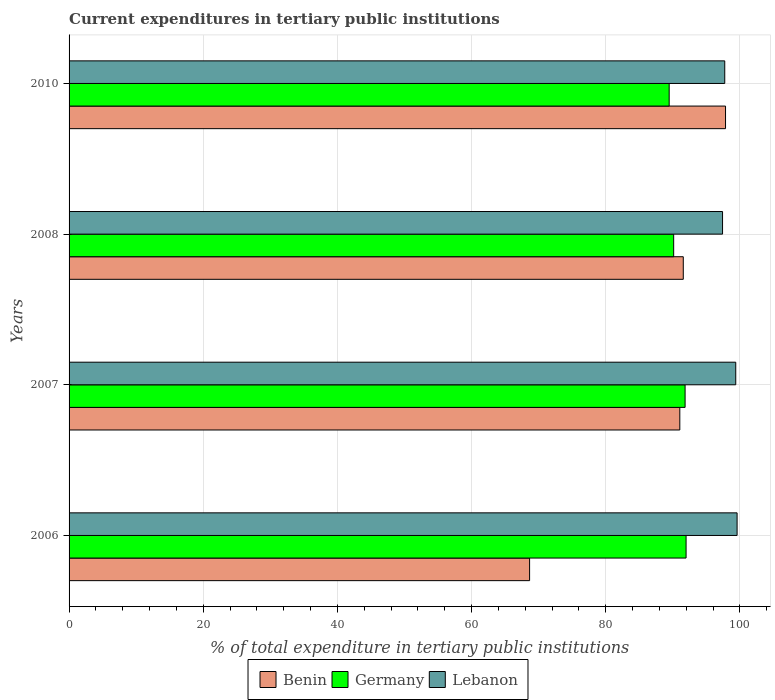How many bars are there on the 2nd tick from the top?
Provide a short and direct response. 3. How many bars are there on the 2nd tick from the bottom?
Ensure brevity in your answer.  3. In how many cases, is the number of bars for a given year not equal to the number of legend labels?
Your answer should be compact. 0. What is the current expenditures in tertiary public institutions in Germany in 2010?
Make the answer very short. 89.45. Across all years, what is the maximum current expenditures in tertiary public institutions in Germany?
Make the answer very short. 91.97. Across all years, what is the minimum current expenditures in tertiary public institutions in Lebanon?
Your response must be concise. 97.41. In which year was the current expenditures in tertiary public institutions in Germany maximum?
Offer a terse response. 2006. In which year was the current expenditures in tertiary public institutions in Germany minimum?
Offer a very short reply. 2010. What is the total current expenditures in tertiary public institutions in Benin in the graph?
Make the answer very short. 349.09. What is the difference between the current expenditures in tertiary public institutions in Germany in 2006 and that in 2010?
Your answer should be very brief. 2.52. What is the difference between the current expenditures in tertiary public institutions in Benin in 2006 and the current expenditures in tertiary public institutions in Germany in 2007?
Ensure brevity in your answer.  -23.18. What is the average current expenditures in tertiary public institutions in Benin per year?
Keep it short and to the point. 87.27. In the year 2006, what is the difference between the current expenditures in tertiary public institutions in Lebanon and current expenditures in tertiary public institutions in Benin?
Offer a very short reply. 30.93. In how many years, is the current expenditures in tertiary public institutions in Germany greater than 52 %?
Provide a short and direct response. 4. What is the ratio of the current expenditures in tertiary public institutions in Germany in 2006 to that in 2008?
Provide a succinct answer. 1.02. Is the difference between the current expenditures in tertiary public institutions in Lebanon in 2006 and 2008 greater than the difference between the current expenditures in tertiary public institutions in Benin in 2006 and 2008?
Provide a succinct answer. Yes. What is the difference between the highest and the second highest current expenditures in tertiary public institutions in Germany?
Your response must be concise. 0.15. What is the difference between the highest and the lowest current expenditures in tertiary public institutions in Germany?
Your response must be concise. 2.52. In how many years, is the current expenditures in tertiary public institutions in Lebanon greater than the average current expenditures in tertiary public institutions in Lebanon taken over all years?
Keep it short and to the point. 2. Is the sum of the current expenditures in tertiary public institutions in Germany in 2008 and 2010 greater than the maximum current expenditures in tertiary public institutions in Benin across all years?
Your response must be concise. Yes. What does the 2nd bar from the top in 2006 represents?
Provide a short and direct response. Germany. What does the 3rd bar from the bottom in 2008 represents?
Provide a short and direct response. Lebanon. Is it the case that in every year, the sum of the current expenditures in tertiary public institutions in Lebanon and current expenditures in tertiary public institutions in Germany is greater than the current expenditures in tertiary public institutions in Benin?
Give a very brief answer. Yes. How many bars are there?
Give a very brief answer. 12. How many years are there in the graph?
Provide a succinct answer. 4. Are the values on the major ticks of X-axis written in scientific E-notation?
Your answer should be very brief. No. Does the graph contain any zero values?
Provide a short and direct response. No. Where does the legend appear in the graph?
Offer a very short reply. Bottom center. How many legend labels are there?
Your answer should be very brief. 3. How are the legend labels stacked?
Provide a succinct answer. Horizontal. What is the title of the graph?
Offer a very short reply. Current expenditures in tertiary public institutions. Does "New Zealand" appear as one of the legend labels in the graph?
Keep it short and to the point. No. What is the label or title of the X-axis?
Make the answer very short. % of total expenditure in tertiary public institutions. What is the % of total expenditure in tertiary public institutions in Benin in 2006?
Make the answer very short. 68.65. What is the % of total expenditure in tertiary public institutions of Germany in 2006?
Your answer should be compact. 91.97. What is the % of total expenditure in tertiary public institutions in Lebanon in 2006?
Ensure brevity in your answer.  99.58. What is the % of total expenditure in tertiary public institutions of Benin in 2007?
Give a very brief answer. 91.04. What is the % of total expenditure in tertiary public institutions in Germany in 2007?
Make the answer very short. 91.83. What is the % of total expenditure in tertiary public institutions in Lebanon in 2007?
Ensure brevity in your answer.  99.38. What is the % of total expenditure in tertiary public institutions of Benin in 2008?
Keep it short and to the point. 91.56. What is the % of total expenditure in tertiary public institutions in Germany in 2008?
Offer a very short reply. 90.12. What is the % of total expenditure in tertiary public institutions of Lebanon in 2008?
Ensure brevity in your answer.  97.41. What is the % of total expenditure in tertiary public institutions in Benin in 2010?
Keep it short and to the point. 97.85. What is the % of total expenditure in tertiary public institutions of Germany in 2010?
Offer a very short reply. 89.45. What is the % of total expenditure in tertiary public institutions in Lebanon in 2010?
Your answer should be compact. 97.74. Across all years, what is the maximum % of total expenditure in tertiary public institutions of Benin?
Your answer should be very brief. 97.85. Across all years, what is the maximum % of total expenditure in tertiary public institutions of Germany?
Keep it short and to the point. 91.97. Across all years, what is the maximum % of total expenditure in tertiary public institutions in Lebanon?
Provide a short and direct response. 99.58. Across all years, what is the minimum % of total expenditure in tertiary public institutions in Benin?
Provide a short and direct response. 68.65. Across all years, what is the minimum % of total expenditure in tertiary public institutions of Germany?
Ensure brevity in your answer.  89.45. Across all years, what is the minimum % of total expenditure in tertiary public institutions in Lebanon?
Your answer should be very brief. 97.41. What is the total % of total expenditure in tertiary public institutions of Benin in the graph?
Your answer should be very brief. 349.09. What is the total % of total expenditure in tertiary public institutions of Germany in the graph?
Your answer should be very brief. 363.37. What is the total % of total expenditure in tertiary public institutions in Lebanon in the graph?
Provide a succinct answer. 394.1. What is the difference between the % of total expenditure in tertiary public institutions in Benin in 2006 and that in 2007?
Your answer should be compact. -22.39. What is the difference between the % of total expenditure in tertiary public institutions of Germany in 2006 and that in 2007?
Your answer should be very brief. 0.15. What is the difference between the % of total expenditure in tertiary public institutions of Lebanon in 2006 and that in 2007?
Provide a succinct answer. 0.2. What is the difference between the % of total expenditure in tertiary public institutions of Benin in 2006 and that in 2008?
Make the answer very short. -22.91. What is the difference between the % of total expenditure in tertiary public institutions of Germany in 2006 and that in 2008?
Offer a very short reply. 1.85. What is the difference between the % of total expenditure in tertiary public institutions in Lebanon in 2006 and that in 2008?
Offer a terse response. 2.17. What is the difference between the % of total expenditure in tertiary public institutions in Benin in 2006 and that in 2010?
Your response must be concise. -29.21. What is the difference between the % of total expenditure in tertiary public institutions of Germany in 2006 and that in 2010?
Your response must be concise. 2.52. What is the difference between the % of total expenditure in tertiary public institutions in Lebanon in 2006 and that in 2010?
Your answer should be compact. 1.84. What is the difference between the % of total expenditure in tertiary public institutions of Benin in 2007 and that in 2008?
Your answer should be compact. -0.52. What is the difference between the % of total expenditure in tertiary public institutions of Germany in 2007 and that in 2008?
Your answer should be very brief. 1.7. What is the difference between the % of total expenditure in tertiary public institutions of Lebanon in 2007 and that in 2008?
Offer a terse response. 1.97. What is the difference between the % of total expenditure in tertiary public institutions of Benin in 2007 and that in 2010?
Make the answer very short. -6.81. What is the difference between the % of total expenditure in tertiary public institutions in Germany in 2007 and that in 2010?
Your answer should be compact. 2.37. What is the difference between the % of total expenditure in tertiary public institutions in Lebanon in 2007 and that in 2010?
Give a very brief answer. 1.64. What is the difference between the % of total expenditure in tertiary public institutions of Benin in 2008 and that in 2010?
Make the answer very short. -6.3. What is the difference between the % of total expenditure in tertiary public institutions of Germany in 2008 and that in 2010?
Provide a short and direct response. 0.67. What is the difference between the % of total expenditure in tertiary public institutions in Lebanon in 2008 and that in 2010?
Your answer should be compact. -0.33. What is the difference between the % of total expenditure in tertiary public institutions in Benin in 2006 and the % of total expenditure in tertiary public institutions in Germany in 2007?
Offer a very short reply. -23.18. What is the difference between the % of total expenditure in tertiary public institutions of Benin in 2006 and the % of total expenditure in tertiary public institutions of Lebanon in 2007?
Offer a terse response. -30.73. What is the difference between the % of total expenditure in tertiary public institutions of Germany in 2006 and the % of total expenditure in tertiary public institutions of Lebanon in 2007?
Your response must be concise. -7.4. What is the difference between the % of total expenditure in tertiary public institutions in Benin in 2006 and the % of total expenditure in tertiary public institutions in Germany in 2008?
Offer a very short reply. -21.48. What is the difference between the % of total expenditure in tertiary public institutions in Benin in 2006 and the % of total expenditure in tertiary public institutions in Lebanon in 2008?
Your response must be concise. -28.76. What is the difference between the % of total expenditure in tertiary public institutions of Germany in 2006 and the % of total expenditure in tertiary public institutions of Lebanon in 2008?
Offer a very short reply. -5.43. What is the difference between the % of total expenditure in tertiary public institutions of Benin in 2006 and the % of total expenditure in tertiary public institutions of Germany in 2010?
Your answer should be compact. -20.81. What is the difference between the % of total expenditure in tertiary public institutions of Benin in 2006 and the % of total expenditure in tertiary public institutions of Lebanon in 2010?
Give a very brief answer. -29.09. What is the difference between the % of total expenditure in tertiary public institutions of Germany in 2006 and the % of total expenditure in tertiary public institutions of Lebanon in 2010?
Your answer should be very brief. -5.76. What is the difference between the % of total expenditure in tertiary public institutions in Benin in 2007 and the % of total expenditure in tertiary public institutions in Germany in 2008?
Your answer should be compact. 0.92. What is the difference between the % of total expenditure in tertiary public institutions in Benin in 2007 and the % of total expenditure in tertiary public institutions in Lebanon in 2008?
Offer a terse response. -6.37. What is the difference between the % of total expenditure in tertiary public institutions of Germany in 2007 and the % of total expenditure in tertiary public institutions of Lebanon in 2008?
Offer a very short reply. -5.58. What is the difference between the % of total expenditure in tertiary public institutions of Benin in 2007 and the % of total expenditure in tertiary public institutions of Germany in 2010?
Your answer should be very brief. 1.59. What is the difference between the % of total expenditure in tertiary public institutions in Benin in 2007 and the % of total expenditure in tertiary public institutions in Lebanon in 2010?
Your response must be concise. -6.7. What is the difference between the % of total expenditure in tertiary public institutions in Germany in 2007 and the % of total expenditure in tertiary public institutions in Lebanon in 2010?
Your answer should be very brief. -5.91. What is the difference between the % of total expenditure in tertiary public institutions in Benin in 2008 and the % of total expenditure in tertiary public institutions in Germany in 2010?
Make the answer very short. 2.1. What is the difference between the % of total expenditure in tertiary public institutions in Benin in 2008 and the % of total expenditure in tertiary public institutions in Lebanon in 2010?
Offer a terse response. -6.18. What is the difference between the % of total expenditure in tertiary public institutions of Germany in 2008 and the % of total expenditure in tertiary public institutions of Lebanon in 2010?
Offer a terse response. -7.61. What is the average % of total expenditure in tertiary public institutions in Benin per year?
Give a very brief answer. 87.27. What is the average % of total expenditure in tertiary public institutions of Germany per year?
Offer a terse response. 90.84. What is the average % of total expenditure in tertiary public institutions of Lebanon per year?
Make the answer very short. 98.52. In the year 2006, what is the difference between the % of total expenditure in tertiary public institutions of Benin and % of total expenditure in tertiary public institutions of Germany?
Your answer should be compact. -23.33. In the year 2006, what is the difference between the % of total expenditure in tertiary public institutions of Benin and % of total expenditure in tertiary public institutions of Lebanon?
Make the answer very short. -30.93. In the year 2006, what is the difference between the % of total expenditure in tertiary public institutions in Germany and % of total expenditure in tertiary public institutions in Lebanon?
Your response must be concise. -7.6. In the year 2007, what is the difference between the % of total expenditure in tertiary public institutions of Benin and % of total expenditure in tertiary public institutions of Germany?
Offer a terse response. -0.79. In the year 2007, what is the difference between the % of total expenditure in tertiary public institutions in Benin and % of total expenditure in tertiary public institutions in Lebanon?
Ensure brevity in your answer.  -8.34. In the year 2007, what is the difference between the % of total expenditure in tertiary public institutions in Germany and % of total expenditure in tertiary public institutions in Lebanon?
Ensure brevity in your answer.  -7.55. In the year 2008, what is the difference between the % of total expenditure in tertiary public institutions of Benin and % of total expenditure in tertiary public institutions of Germany?
Ensure brevity in your answer.  1.43. In the year 2008, what is the difference between the % of total expenditure in tertiary public institutions of Benin and % of total expenditure in tertiary public institutions of Lebanon?
Your answer should be compact. -5.85. In the year 2008, what is the difference between the % of total expenditure in tertiary public institutions in Germany and % of total expenditure in tertiary public institutions in Lebanon?
Ensure brevity in your answer.  -7.29. In the year 2010, what is the difference between the % of total expenditure in tertiary public institutions of Benin and % of total expenditure in tertiary public institutions of Germany?
Provide a succinct answer. 8.4. In the year 2010, what is the difference between the % of total expenditure in tertiary public institutions in Benin and % of total expenditure in tertiary public institutions in Lebanon?
Give a very brief answer. 0.12. In the year 2010, what is the difference between the % of total expenditure in tertiary public institutions of Germany and % of total expenditure in tertiary public institutions of Lebanon?
Offer a very short reply. -8.28. What is the ratio of the % of total expenditure in tertiary public institutions in Benin in 2006 to that in 2007?
Your answer should be very brief. 0.75. What is the ratio of the % of total expenditure in tertiary public institutions of Benin in 2006 to that in 2008?
Offer a very short reply. 0.75. What is the ratio of the % of total expenditure in tertiary public institutions of Germany in 2006 to that in 2008?
Keep it short and to the point. 1.02. What is the ratio of the % of total expenditure in tertiary public institutions in Lebanon in 2006 to that in 2008?
Offer a terse response. 1.02. What is the ratio of the % of total expenditure in tertiary public institutions in Benin in 2006 to that in 2010?
Keep it short and to the point. 0.7. What is the ratio of the % of total expenditure in tertiary public institutions of Germany in 2006 to that in 2010?
Your answer should be very brief. 1.03. What is the ratio of the % of total expenditure in tertiary public institutions of Lebanon in 2006 to that in 2010?
Provide a succinct answer. 1.02. What is the ratio of the % of total expenditure in tertiary public institutions of Germany in 2007 to that in 2008?
Ensure brevity in your answer.  1.02. What is the ratio of the % of total expenditure in tertiary public institutions of Lebanon in 2007 to that in 2008?
Your answer should be compact. 1.02. What is the ratio of the % of total expenditure in tertiary public institutions of Benin in 2007 to that in 2010?
Your answer should be compact. 0.93. What is the ratio of the % of total expenditure in tertiary public institutions of Germany in 2007 to that in 2010?
Your answer should be very brief. 1.03. What is the ratio of the % of total expenditure in tertiary public institutions of Lebanon in 2007 to that in 2010?
Provide a short and direct response. 1.02. What is the ratio of the % of total expenditure in tertiary public institutions in Benin in 2008 to that in 2010?
Give a very brief answer. 0.94. What is the ratio of the % of total expenditure in tertiary public institutions of Germany in 2008 to that in 2010?
Your answer should be very brief. 1.01. What is the difference between the highest and the second highest % of total expenditure in tertiary public institutions in Benin?
Make the answer very short. 6.3. What is the difference between the highest and the second highest % of total expenditure in tertiary public institutions of Germany?
Keep it short and to the point. 0.15. What is the difference between the highest and the second highest % of total expenditure in tertiary public institutions of Lebanon?
Make the answer very short. 0.2. What is the difference between the highest and the lowest % of total expenditure in tertiary public institutions in Benin?
Keep it short and to the point. 29.21. What is the difference between the highest and the lowest % of total expenditure in tertiary public institutions in Germany?
Make the answer very short. 2.52. What is the difference between the highest and the lowest % of total expenditure in tertiary public institutions in Lebanon?
Offer a very short reply. 2.17. 